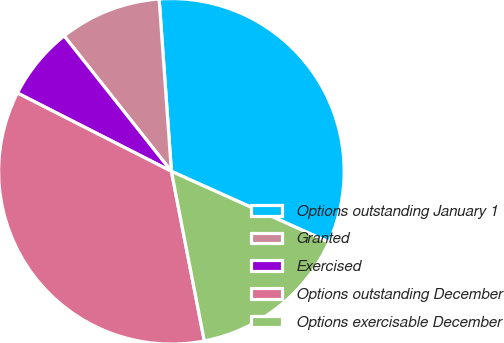Convert chart to OTSL. <chart><loc_0><loc_0><loc_500><loc_500><pie_chart><fcel>Options outstanding January 1<fcel>Granted<fcel>Exercised<fcel>Options outstanding December<fcel>Options exercisable December<nl><fcel>32.86%<fcel>9.53%<fcel>6.85%<fcel>35.54%<fcel>15.22%<nl></chart> 